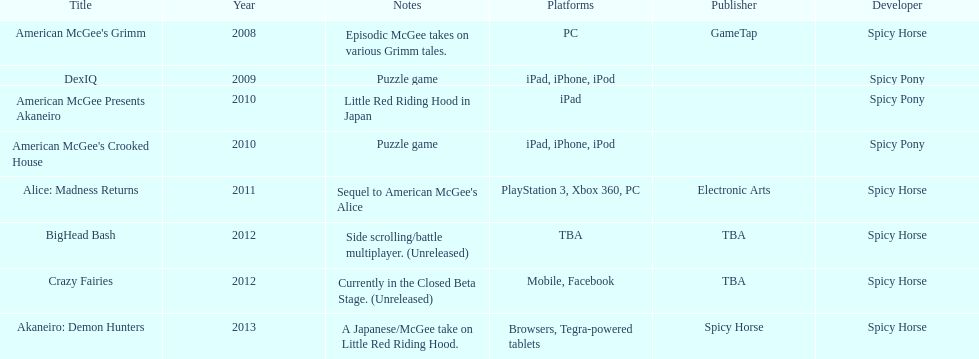How many games did spicy horse develop in total? 5. 